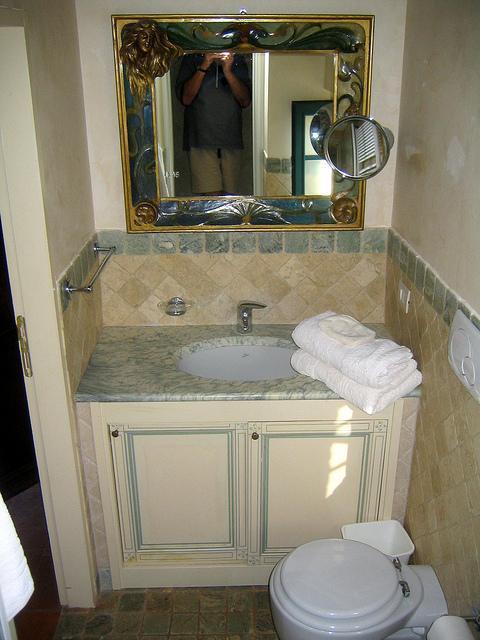How many different types of tiles were used in this bathroom?
Give a very brief answer. 2. How many towels are there?
Give a very brief answer. 2. 